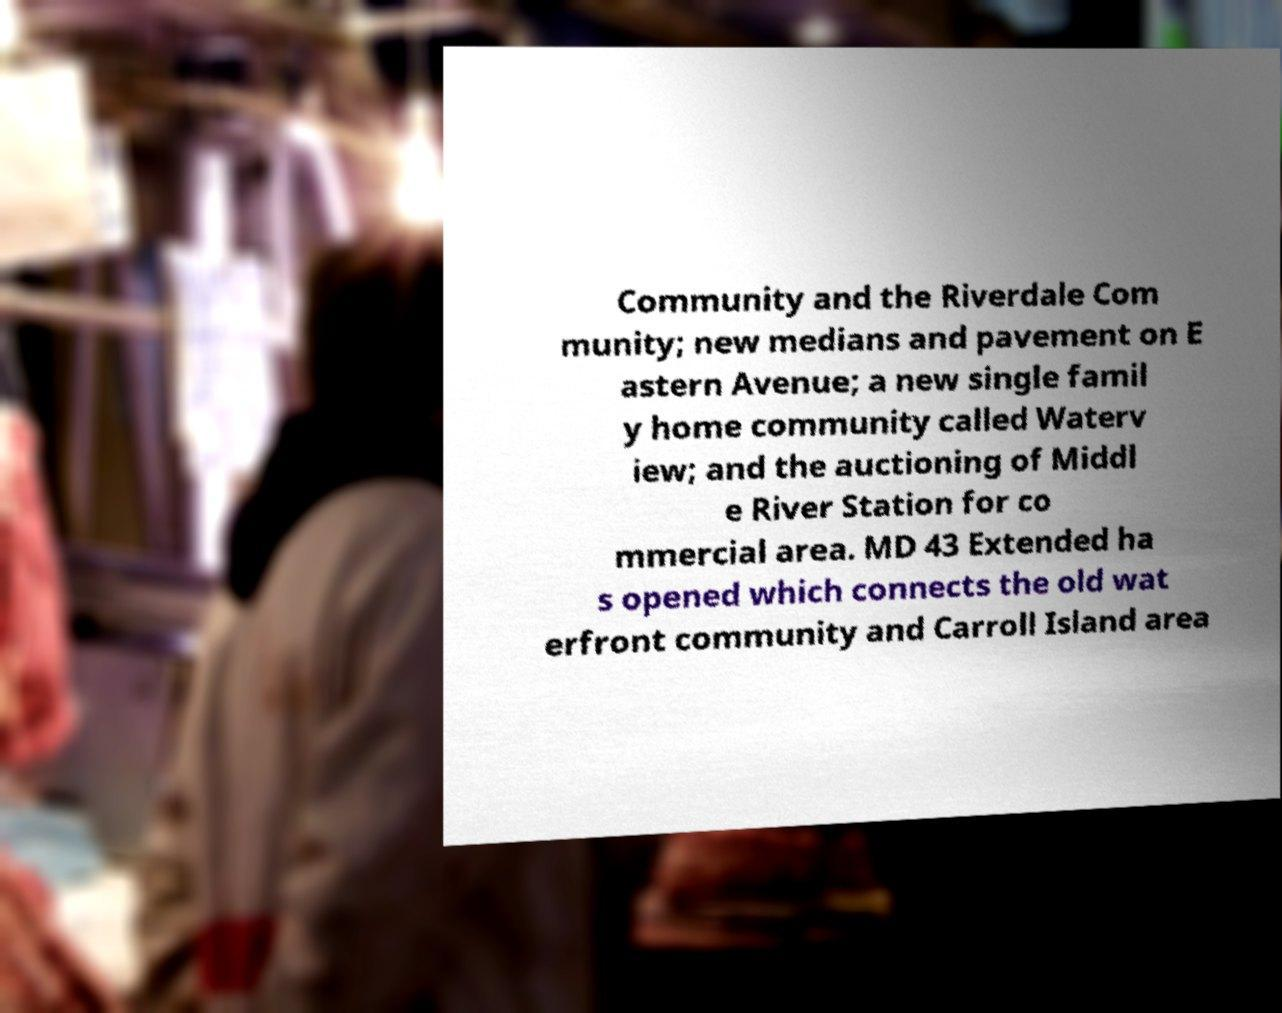Could you assist in decoding the text presented in this image and type it out clearly? Community and the Riverdale Com munity; new medians and pavement on E astern Avenue; a new single famil y home community called Waterv iew; and the auctioning of Middl e River Station for co mmercial area. MD 43 Extended ha s opened which connects the old wat erfront community and Carroll Island area 